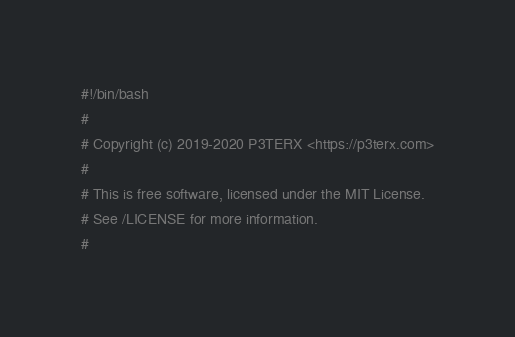<code> <loc_0><loc_0><loc_500><loc_500><_Bash_>#!/bin/bash
#
# Copyright (c) 2019-2020 P3TERX <https://p3terx.com>
#
# This is free software, licensed under the MIT License.
# See /LICENSE for more information.
#</code> 